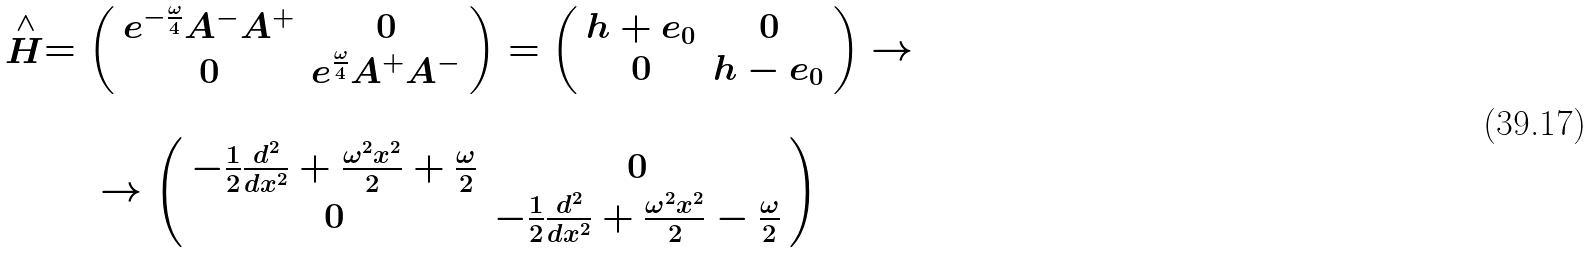<formula> <loc_0><loc_0><loc_500><loc_500>\begin{array} { c } \stackrel { \wedge } { H } = \left ( \begin{array} { c c } e ^ { - \frac { \omega } { 4 } } A ^ { - } A ^ { + } & 0 \\ 0 & e ^ { \frac { \omega } { 4 } } A ^ { + } A ^ { - } \end{array} \right ) = \left ( \begin{array} { c c } h + e _ { 0 } & 0 \\ 0 & h - e _ { 0 } \end{array} \right ) \rightarrow \\ \\ \rightarrow \left ( \begin{array} { c c } - \frac { 1 } { 2 } \frac { d ^ { 2 } } { d x ^ { 2 } } + \frac { \omega ^ { 2 } x ^ { 2 } } { 2 } + \frac { \omega } { 2 } & 0 \\ 0 & - \frac { 1 } { 2 } \frac { d ^ { 2 } } { d x ^ { 2 } } + \frac { \omega ^ { 2 } x ^ { 2 } } { 2 } - \frac { \omega } { 2 } \end{array} \right ) \end{array}</formula> 